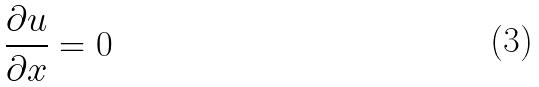Convert formula to latex. <formula><loc_0><loc_0><loc_500><loc_500>\frac { \partial u } { \partial x } = 0</formula> 